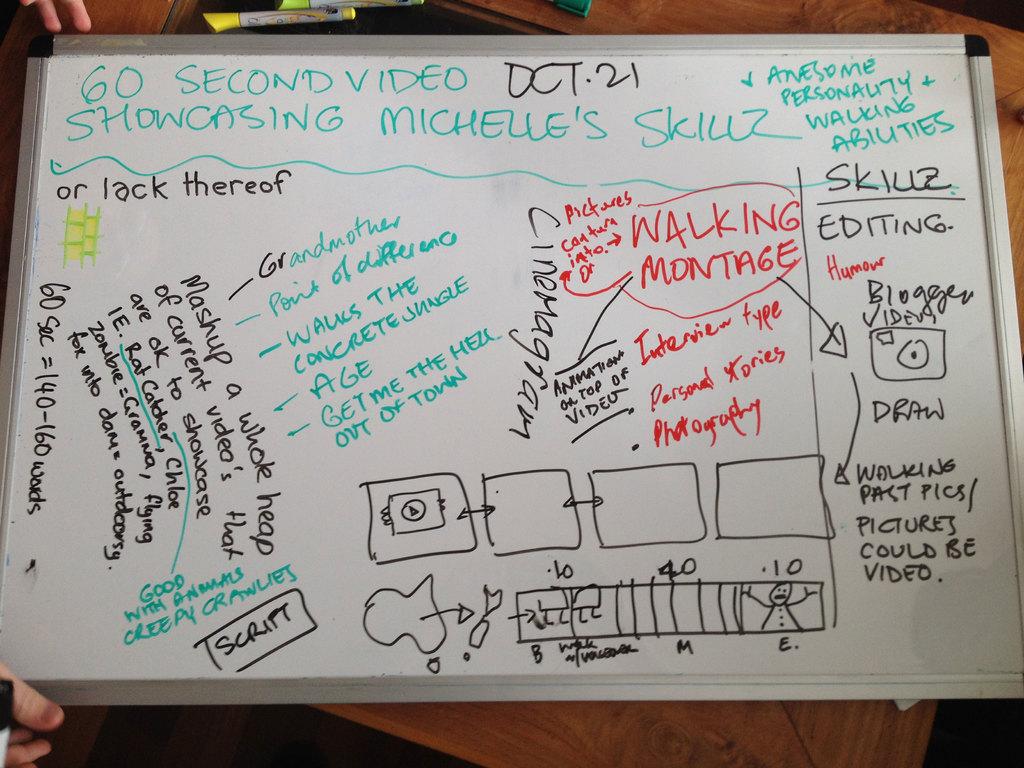What date is on the board?
Your answer should be compact. Oct. 21. 